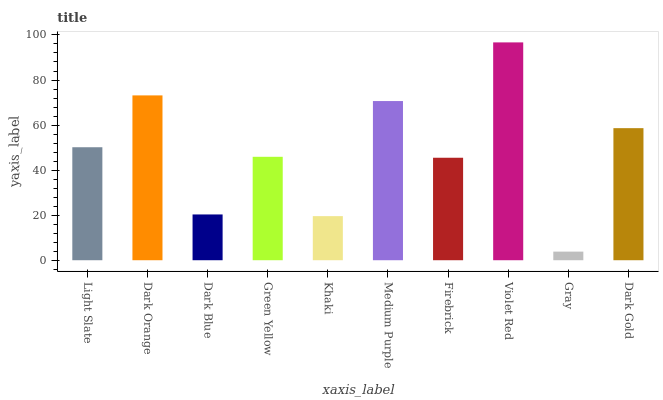Is Gray the minimum?
Answer yes or no. Yes. Is Violet Red the maximum?
Answer yes or no. Yes. Is Dark Orange the minimum?
Answer yes or no. No. Is Dark Orange the maximum?
Answer yes or no. No. Is Dark Orange greater than Light Slate?
Answer yes or no. Yes. Is Light Slate less than Dark Orange?
Answer yes or no. Yes. Is Light Slate greater than Dark Orange?
Answer yes or no. No. Is Dark Orange less than Light Slate?
Answer yes or no. No. Is Light Slate the high median?
Answer yes or no. Yes. Is Green Yellow the low median?
Answer yes or no. Yes. Is Dark Gold the high median?
Answer yes or no. No. Is Firebrick the low median?
Answer yes or no. No. 